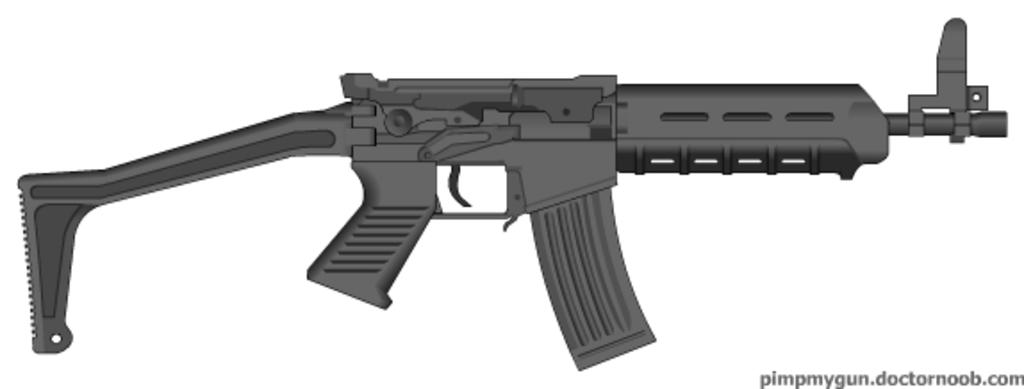What type of object is depicted in the image? There is an animated rifle in the image. Is there any additional information or branding present in the image? Yes, there is a watermark in the image. What type of mint can be seen in the image? There is no mint present in the image; it features an animated rifle and a watermark. How does the rifle kick in the image? The rifle does not kick in the image, as it is an animated representation and not a real object. 